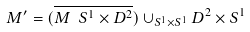<formula> <loc_0><loc_0><loc_500><loc_500>M ^ { \prime } = ( \overline { M \ S ^ { 1 } \times D ^ { 2 } } ) \cup _ { S ^ { 1 } \times S ^ { 1 } } D ^ { 2 } \times S ^ { 1 }</formula> 